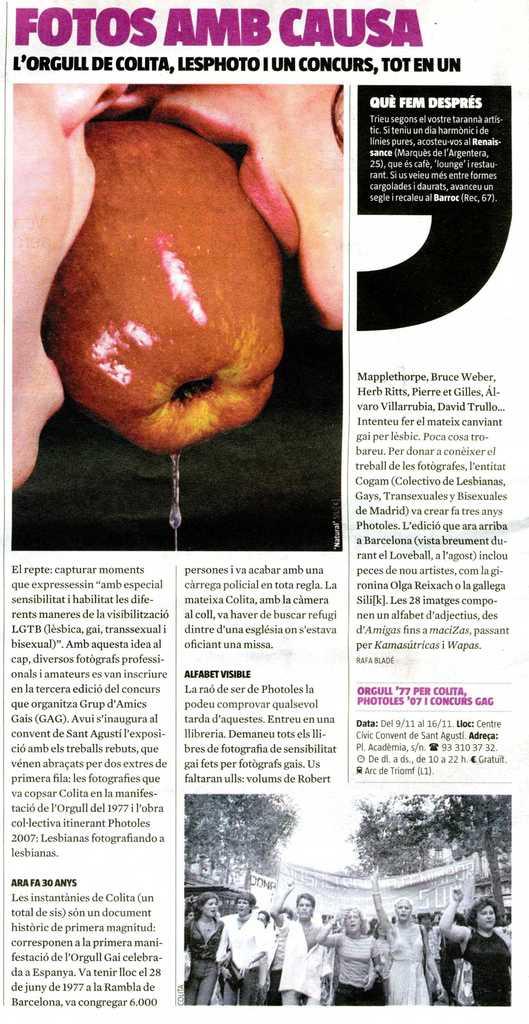What is shown?
Your answer should be compact. Apple. 